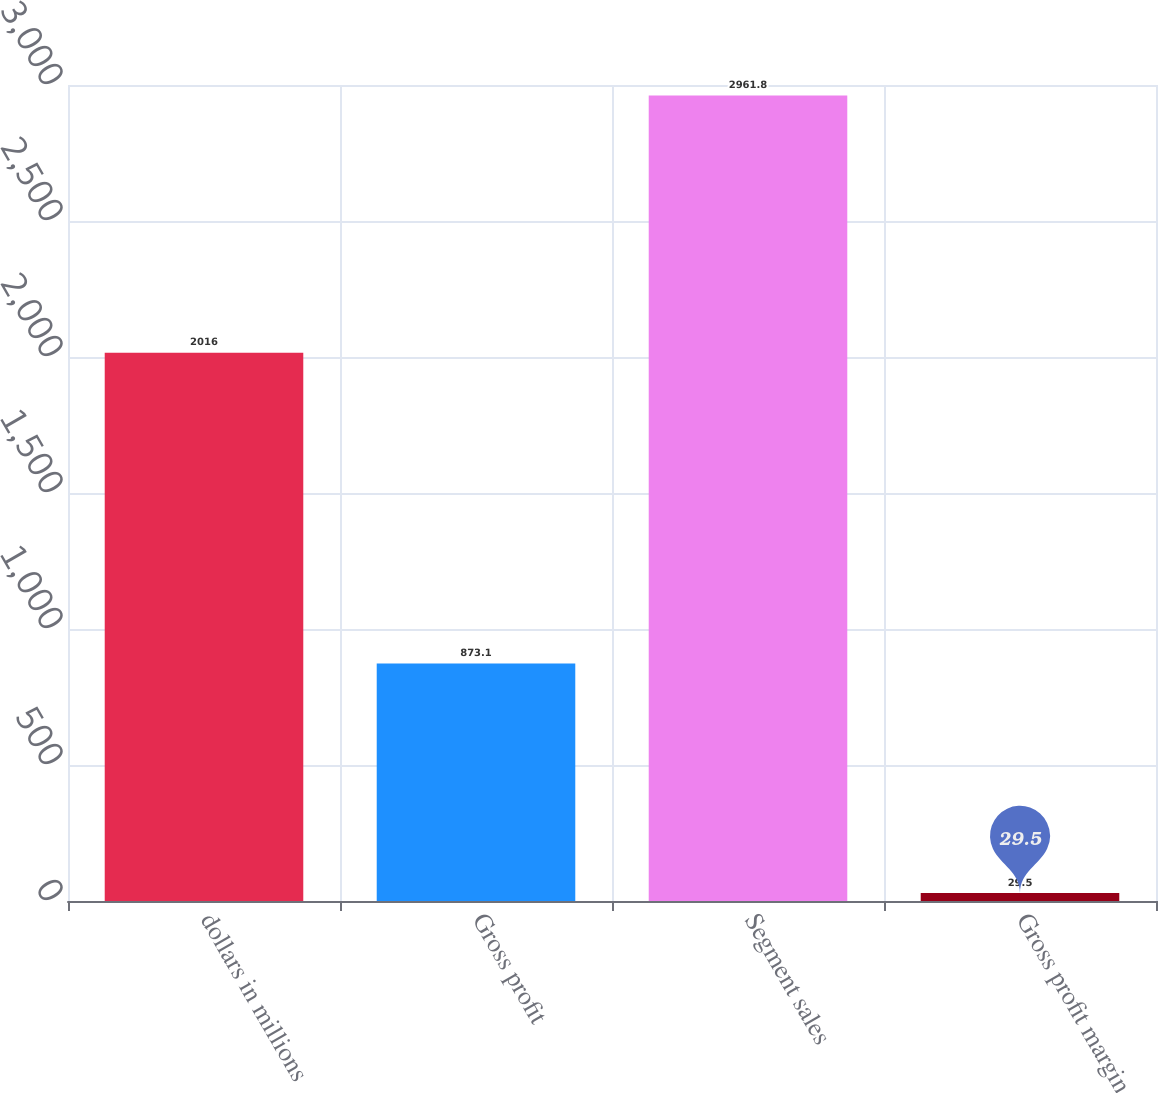<chart> <loc_0><loc_0><loc_500><loc_500><bar_chart><fcel>dollars in millions<fcel>Gross profit<fcel>Segment sales<fcel>Gross profit margin<nl><fcel>2016<fcel>873.1<fcel>2961.8<fcel>29.5<nl></chart> 